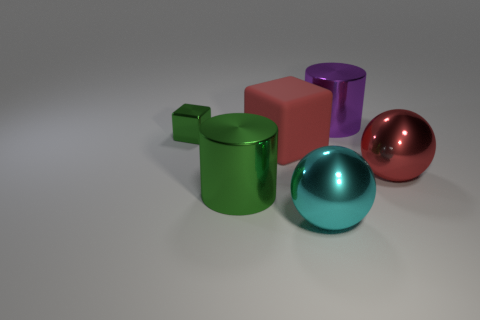Is there any other thing that has the same material as the large block?
Your response must be concise. No. The shiny cube has what color?
Provide a succinct answer. Green. What color is the object that is left of the green cylinder?
Make the answer very short. Green. There is a metallic cylinder that is on the left side of the purple shiny object; what number of shiny things are on the right side of it?
Make the answer very short. 3. There is a cyan metal sphere; does it have the same size as the block that is in front of the small thing?
Provide a succinct answer. Yes. Are there any red objects of the same size as the cyan metal ball?
Give a very brief answer. Yes. How many objects are either cyan objects or big red shiny balls?
Provide a succinct answer. 2. There is a purple cylinder right of the large cyan object; does it have the same size as the green object behind the large red metal sphere?
Ensure brevity in your answer.  No. Is there another thing that has the same shape as the large matte object?
Keep it short and to the point. Yes. Are there fewer small green things on the right side of the tiny green object than big purple spheres?
Provide a succinct answer. No. 